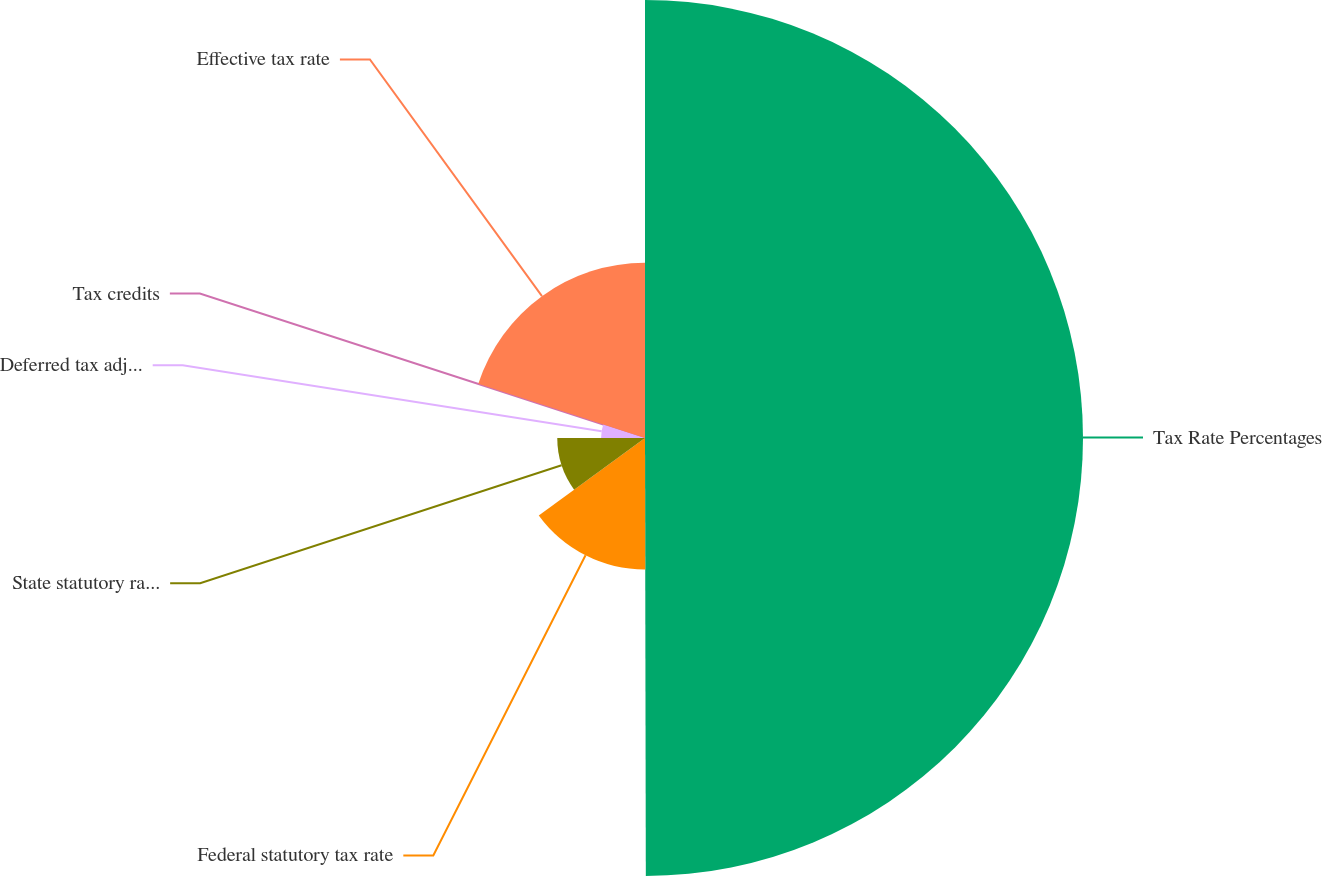Convert chart. <chart><loc_0><loc_0><loc_500><loc_500><pie_chart><fcel>Tax Rate Percentages<fcel>Federal statutory tax rate<fcel>State statutory rates net of<fcel>Deferred tax adjustments<fcel>Tax credits<fcel>Effective tax rate<nl><fcel>49.97%<fcel>15.0%<fcel>10.01%<fcel>5.01%<fcel>0.01%<fcel>20.0%<nl></chart> 